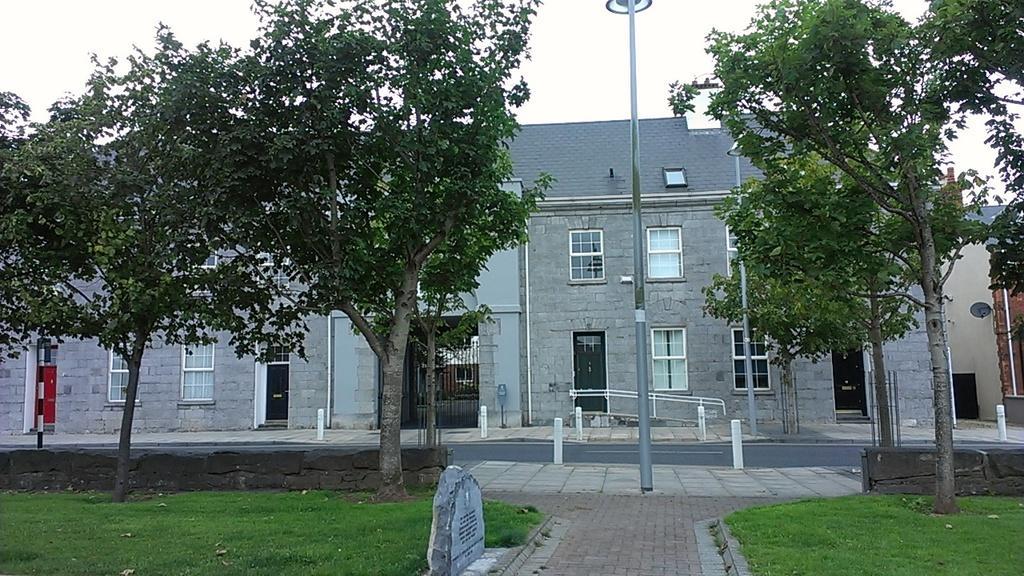Can you describe this image briefly? In this image there is a building with a metal grill entrance and glass windows, in front of the building there is a lamp post and trees and there is a pavement, beside the pavement there is grass. 